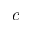<formula> <loc_0><loc_0><loc_500><loc_500>c</formula> 